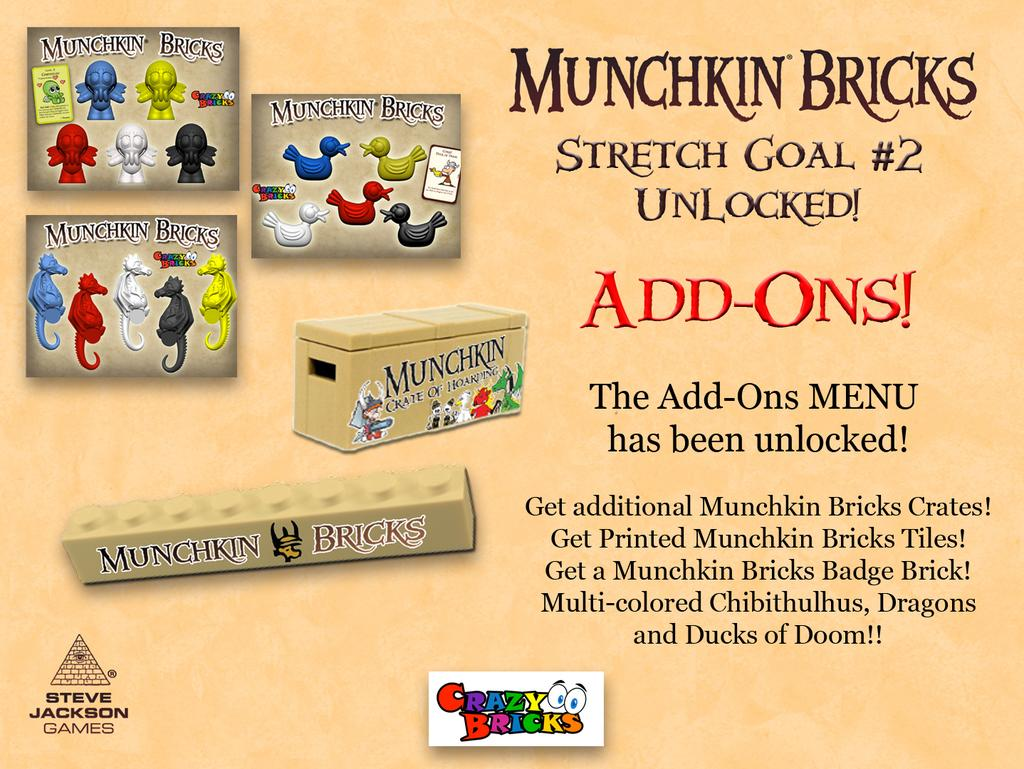Provide a one-sentence caption for the provided image. A bunch of different Munchkin Brick boxes near each other. 